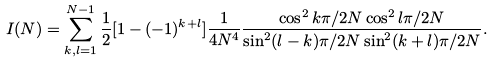<formula> <loc_0><loc_0><loc_500><loc_500>I ( N ) = \sum _ { k , l = 1 } ^ { N - 1 } \frac { 1 } { 2 } [ 1 - ( - 1 ) ^ { k + l } ] \frac { 1 } { 4 N ^ { 4 } } \frac { \cos ^ { 2 } k \pi / 2 N \cos ^ { 2 } l \pi / 2 N } { \sin ^ { 2 } ( l - k ) \pi / 2 N \sin ^ { 2 } ( k + l ) \pi / 2 N } .</formula> 